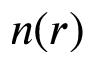<formula> <loc_0><loc_0><loc_500><loc_500>n ( r )</formula> 